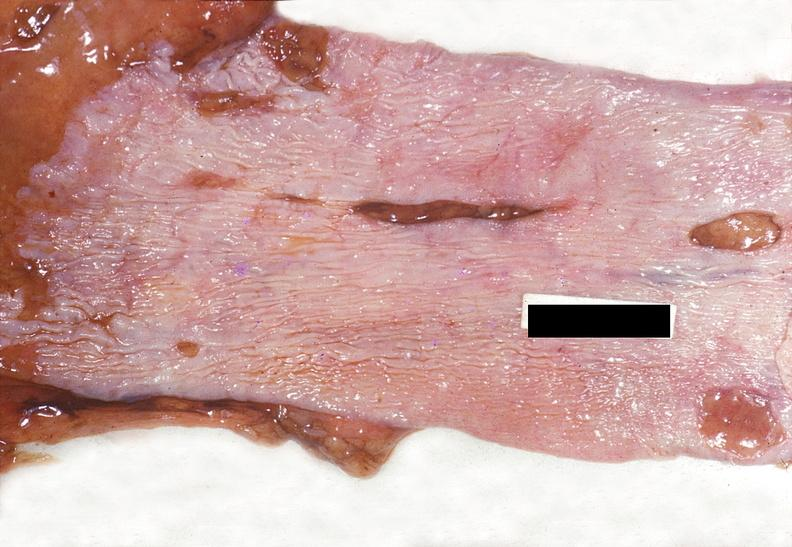what does this image show?
Answer the question using a single word or phrase. Esophagus 